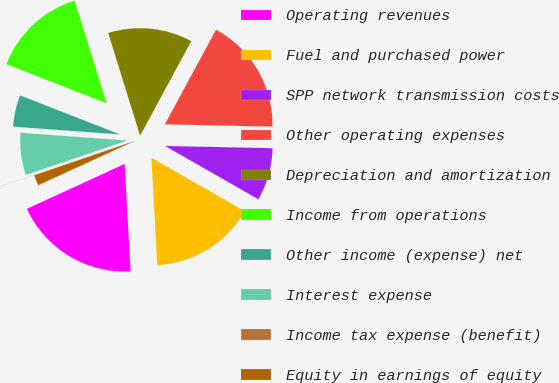Convert chart to OTSL. <chart><loc_0><loc_0><loc_500><loc_500><pie_chart><fcel>Operating revenues<fcel>Fuel and purchased power<fcel>SPP network transmission costs<fcel>Other operating expenses<fcel>Depreciation and amortization<fcel>Income from operations<fcel>Other income (expense) net<fcel>Interest expense<fcel>Income tax expense (benefit)<fcel>Equity in earnings of equity<nl><fcel>19.02%<fcel>15.86%<fcel>7.94%<fcel>17.44%<fcel>12.69%<fcel>14.27%<fcel>4.78%<fcel>6.36%<fcel>0.03%<fcel>1.61%<nl></chart> 